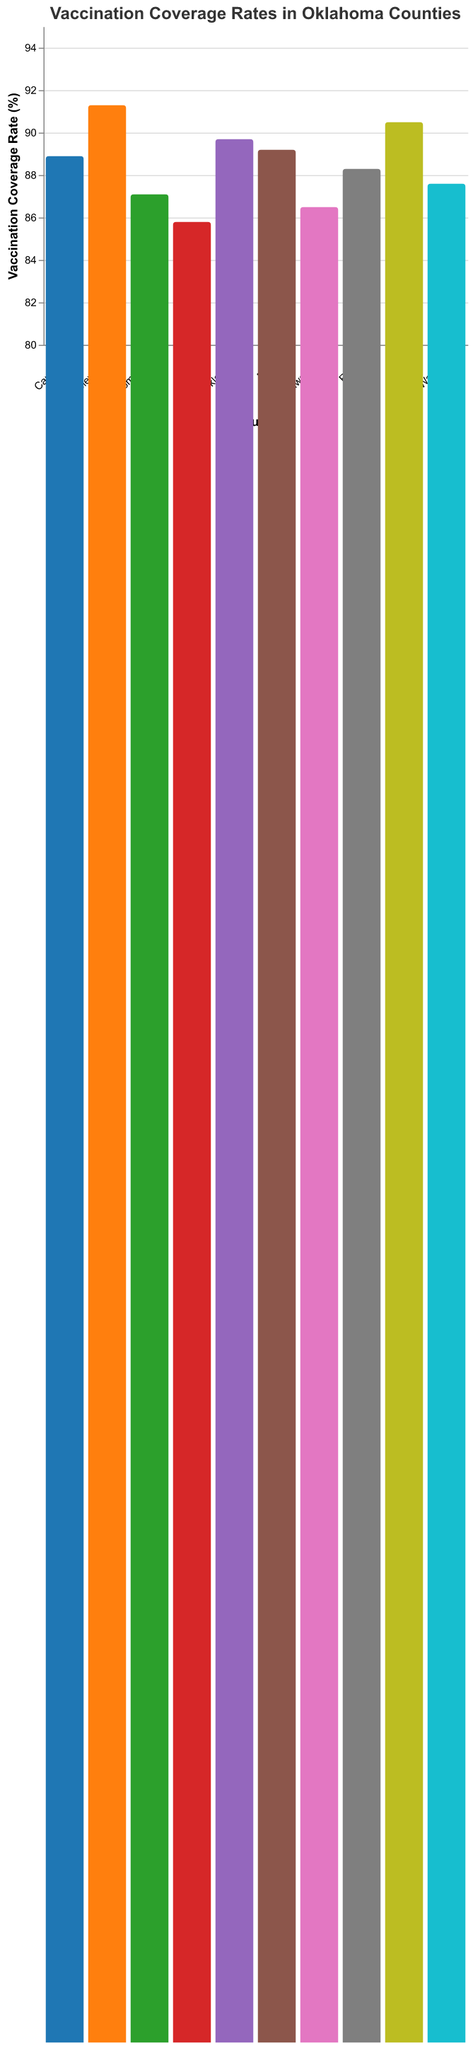What is the vaccination coverage rate for the 65+ age group in Oklahoma County? The y-axis shows the vaccination coverage rate for the 65+ age group, and the bar chart shows the coverage rate for Oklahoma County.
Answer: 89.7% Which county has the highest vaccination coverage rate for the 65+ age group? By examining the heights of the bars corresponding to the 65+ age group, Cleveland County has the tallest bar, indicating the highest rate.
Answer: Cleveland Compare the vaccination coverage rates for the 65+ age group between Tulsa and Comanche counties. Which one is higher? By comparing the heights of the bars for the 65+ age group in Tulsa and Comanche counties, the bar for Tulsa County is higher.
Answer: Tulsa What is the difference in vaccination coverage rates for the 65+ age group between Rogers and Creek counties? The rates are 88.3% for Rogers and 85.8% for Creek. The difference is calculated as 88.3 - 85.8.
Answer: 2.5% Which counties have vaccination coverage rates for the 65+ age group below 88%? Looking at the y-axis and the heights of the bars, Comanche, Pottawatomie, and Creek counties have bars below 88%.
Answer: Comanche, Pottawatomie, Creek What is the average vaccination coverage rate for the 65+ age group across all counties listed? Add the coverage rates for all counties and divide by the number of counties: (89.7 + 91.3 + 88.9 + 90.5 + 87.1 + 89.2 + 86.5 + 85.8 + 88.3 + 87.6)/10.
Answer: 88.49% By how much does the vaccination coverage rate for the 65+ age group in Pottawatomie County fall short of Cleveland County? Cleveland County has a rate of 91.3%, and Pottawatomie County has a rate of 86.5%. Calculate 91.3 - 86.5.
Answer: 4.8% Which two counties have the closest vaccination coverage rates for the 65+ age group? Observe the heights of the bars and find the two closest. Oklahoma and Payne counties have rates of 89.7% and 89.2%, respectively, making the difference 0.5.
Answer: Oklahoma, Payne 